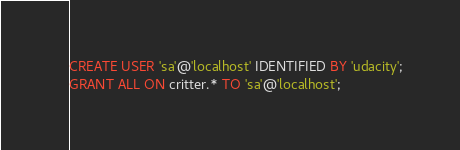Convert code to text. <code><loc_0><loc_0><loc_500><loc_500><_SQL_>CREATE USER 'sa'@'localhost' IDENTIFIED BY 'udacity';
GRANT ALL ON critter.* TO 'sa'@'localhost';</code> 